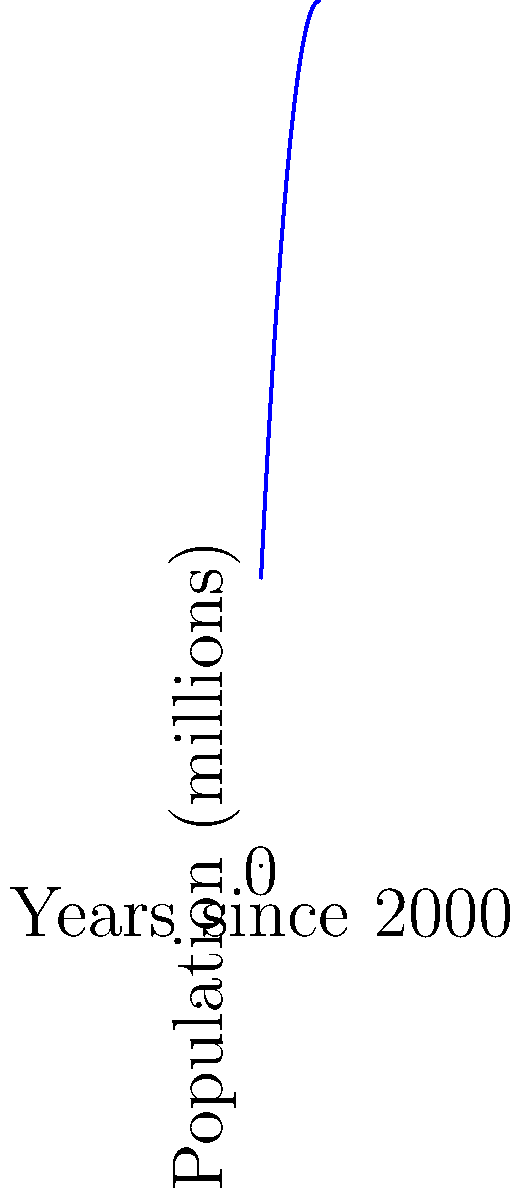As a government advisor analyzing population growth trends, what critical insight would you provide about the practical implications of the population trajectory shown in the graph between points B and C for long-term resource allocation and policy planning? To answer this question, we need to analyze the graph and its implications step-by-step:

1. Observe the overall trend: The graph shows a population growth curve that increases, reaches a peak, and then starts to decline.

2. Identify key points:
   - Point A: Early growth phase
   - Point B: Peak population
   - Point C: Declining phase

3. Focus on the section between B and C:
   - This represents a transition from peak population to decline.
   - The curve is concave down, indicating an accelerating rate of population decrease.

4. Implications for resource allocation and policy planning:
   - Changing demographics: An aging population is likely as growth slows and reverses.
   - Shifting resource needs: Less demand for new infrastructure, more for healthcare and elderly care.
   - Economic impacts: Potential labor shortages and changes in consumer markets.
   - Pension and social security systems: May face increasing strain with fewer workers supporting more retirees.
   - Education and childcare: Decreasing demand over time.
   - Housing market: Potential oversupply in some areas as population declines.

5. Critical insight for long-term planning:
   - The transition from growth to decline requires a fundamental shift in policy approach.
   - Policies need to be adaptable and forward-looking, anticipating the challenges of a shrinking population.
   - Focus should be on maintaining productivity and quality of life with a smaller, older population.
   - International policies may need to consider immigration to balance demographic shifts.

The most critical insight is the need for a paradigm shift from managing growth to managing decline, with policies that address the challenges of an aging, shrinking population while maintaining economic stability and social well-being.
Answer: Shift from growth-oriented to decline-management policies, focusing on aging population needs and economic stability. 